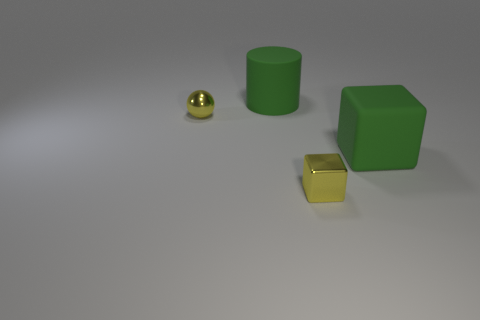There is a small object that is the same color as the metal block; what material is it?
Make the answer very short. Metal. Do the tiny cube and the tiny sphere have the same color?
Provide a succinct answer. Yes. There is a thing that is the same size as the shiny sphere; what is it made of?
Your response must be concise. Metal. Is the material of the yellow cube the same as the big cube?
Your response must be concise. No. What number of big green blocks have the same material as the large cylinder?
Your response must be concise. 1. What number of objects are large things in front of the shiny ball or green things that are in front of the yellow metal sphere?
Ensure brevity in your answer.  1. Is the number of shiny spheres that are in front of the rubber cylinder greater than the number of tiny shiny things in front of the shiny ball?
Offer a terse response. No. The thing that is in front of the big matte block is what color?
Offer a very short reply. Yellow. How many brown objects are either rubber cylinders or tiny blocks?
Offer a very short reply. 0. Are there any yellow metallic things of the same size as the shiny cube?
Provide a succinct answer. Yes. 